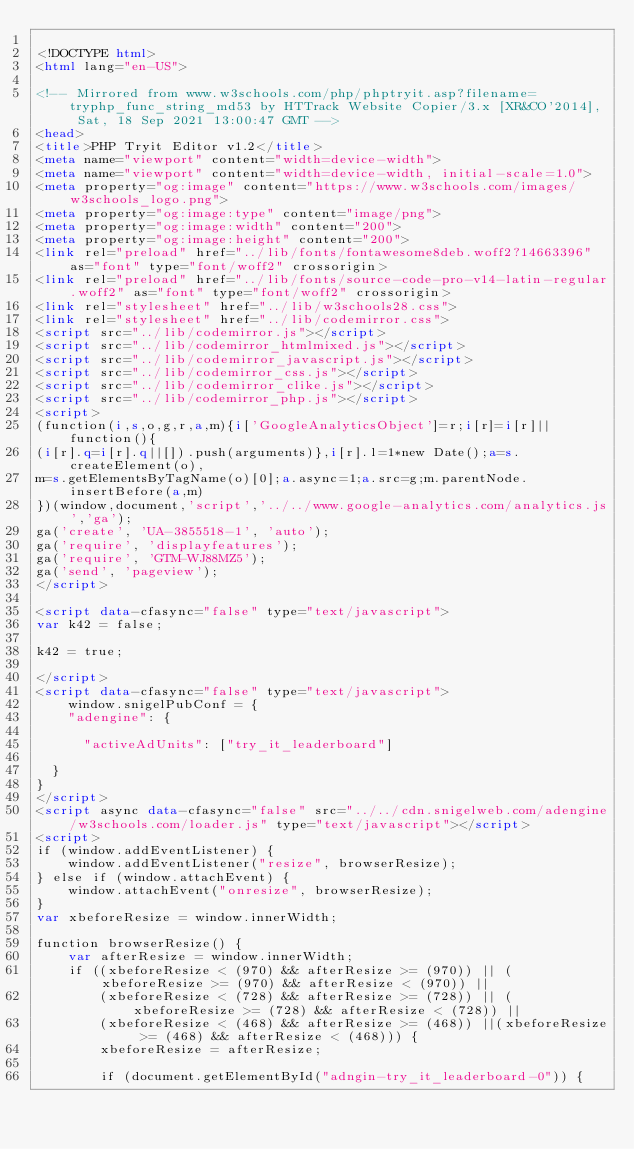<code> <loc_0><loc_0><loc_500><loc_500><_HTML_>
<!DOCTYPE html>
<html lang="en-US">

<!-- Mirrored from www.w3schools.com/php/phptryit.asp?filename=tryphp_func_string_md53 by HTTrack Website Copier/3.x [XR&CO'2014], Sat, 18 Sep 2021 13:00:47 GMT -->
<head>
<title>PHP Tryit Editor v1.2</title>
<meta name="viewport" content="width=device-width">
<meta name="viewport" content="width=device-width, initial-scale=1.0">
<meta property="og:image" content="https://www.w3schools.com/images/w3schools_logo.png">
<meta property="og:image:type" content="image/png">
<meta property="og:image:width" content="200">
<meta property="og:image:height" content="200">
<link rel="preload" href="../lib/fonts/fontawesome8deb.woff2?14663396" as="font" type="font/woff2" crossorigin> 
<link rel="preload" href="../lib/fonts/source-code-pro-v14-latin-regular.woff2" as="font" type="font/woff2" crossorigin> 
<link rel="stylesheet" href="../lib/w3schools28.css">
<link rel="stylesheet" href="../lib/codemirror.css">
<script src="../lib/codemirror.js"></script>
<script src="../lib/codemirror_htmlmixed.js"></script>
<script src="../lib/codemirror_javascript.js"></script>
<script src="../lib/codemirror_css.js"></script>
<script src="../lib/codemirror_clike.js"></script>
<script src="../lib/codemirror_php.js"></script>
<script>
(function(i,s,o,g,r,a,m){i['GoogleAnalyticsObject']=r;i[r]=i[r]||function(){
(i[r].q=i[r].q||[]).push(arguments)},i[r].l=1*new Date();a=s.createElement(o),
m=s.getElementsByTagName(o)[0];a.async=1;a.src=g;m.parentNode.insertBefore(a,m)
})(window,document,'script','../../www.google-analytics.com/analytics.js','ga');
ga('create', 'UA-3855518-1', 'auto');
ga('require', 'displayfeatures');
ga('require', 'GTM-WJ88MZ5');
ga('send', 'pageview');
</script>

<script data-cfasync="false" type="text/javascript">
var k42 = false;

k42 = true;

</script>
<script data-cfasync="false" type="text/javascript">
    window.snigelPubConf = {
    "adengine": {

      "activeAdUnits": ["try_it_leaderboard"]

  }
}
</script>
<script async data-cfasync="false" src="../../cdn.snigelweb.com/adengine/w3schools.com/loader.js" type="text/javascript"></script>
<script>
if (window.addEventListener) {              
    window.addEventListener("resize", browserResize);
} else if (window.attachEvent) {                 
    window.attachEvent("onresize", browserResize);
}
var xbeforeResize = window.innerWidth;

function browserResize() {
    var afterResize = window.innerWidth;
    if ((xbeforeResize < (970) && afterResize >= (970)) || (xbeforeResize >= (970) && afterResize < (970)) ||
        (xbeforeResize < (728) && afterResize >= (728)) || (xbeforeResize >= (728) && afterResize < (728)) ||
        (xbeforeResize < (468) && afterResize >= (468)) ||(xbeforeResize >= (468) && afterResize < (468))) {
        xbeforeResize = afterResize;
        
        if (document.getElementById("adngin-try_it_leaderboard-0")) {</code> 